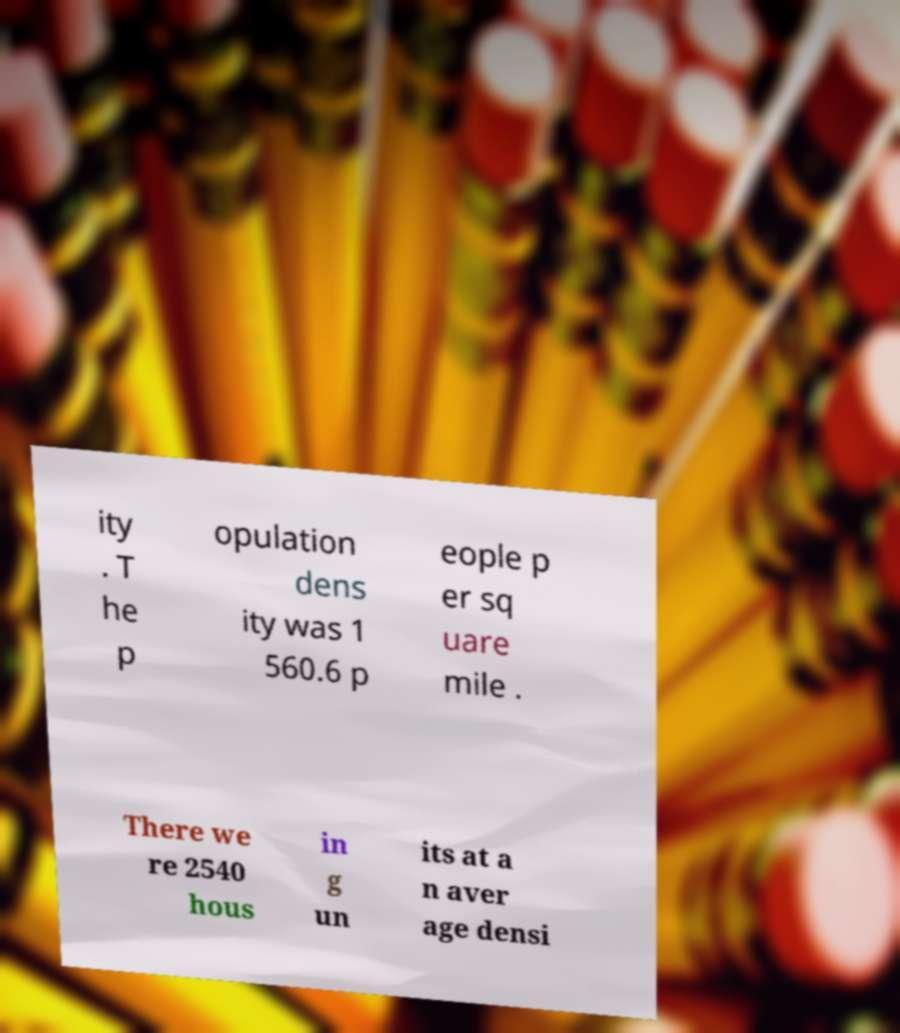Please read and relay the text visible in this image. What does it say? ity . T he p opulation dens ity was 1 560.6 p eople p er sq uare mile . There we re 2540 hous in g un its at a n aver age densi 